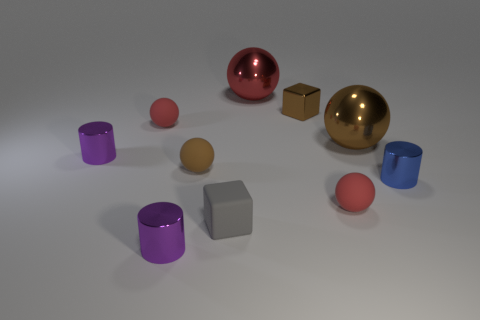Subtract all brown balls. How many balls are left? 3 Subtract all gray cylinders. How many red spheres are left? 3 Subtract all brown balls. How many balls are left? 3 Subtract 1 cylinders. How many cylinders are left? 2 Subtract all cylinders. How many objects are left? 7 Subtract all rubber cubes. Subtract all red things. How many objects are left? 6 Add 5 red objects. How many red objects are left? 8 Add 4 tiny blue metallic things. How many tiny blue metallic things exist? 5 Subtract 0 purple spheres. How many objects are left? 10 Subtract all brown cylinders. Subtract all green balls. How many cylinders are left? 3 